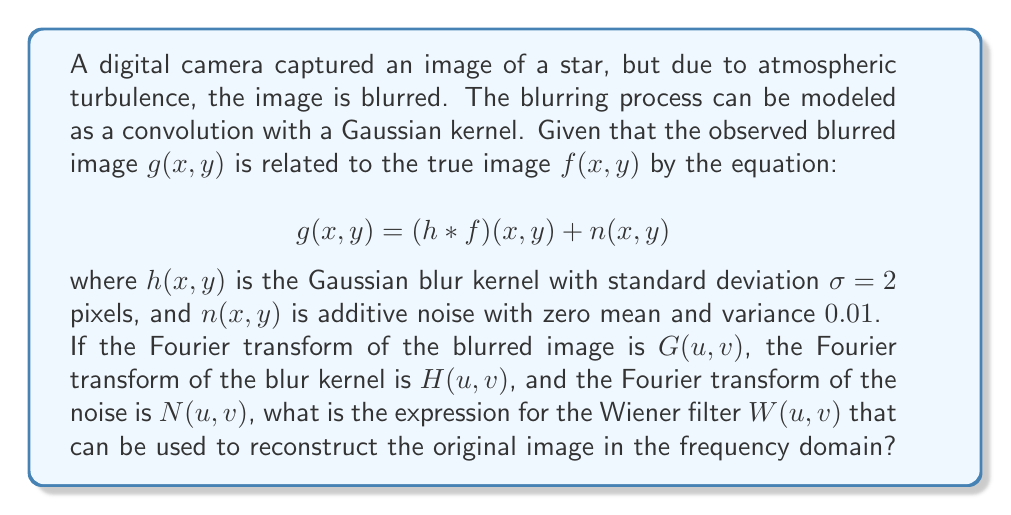Can you answer this question? Let's approach this step-by-step:

1) The Wiener filter is a technique used for deconvolution in the presence of noise. It aims to minimize the mean square error between the estimated and true images.

2) The general form of the Wiener filter in the frequency domain is:

   $$W(u,v) = \frac{H^*(u,v)}{|H(u,v)|^2 + K}$$

   where $H^*(u,v)$ is the complex conjugate of $H(u,v)$, and $K$ is a constant related to the noise-to-signal ratio.

3) For a Gaussian blur kernel with standard deviation $\sigma$, the Fourier transform $H(u,v)$ is:

   $$H(u,v) = e^{-2\pi^2\sigma^2(u^2+v^2)}$$

4) The constant $K$ is typically chosen as the ratio of the noise power spectrum to the signal power spectrum. In this case, we're given that the noise has zero mean and variance 0.01. Assuming the signal and noise are uncorrelated, we can approximate $K$ as:

   $$K \approx \frac{\text{Noise Variance}}{\text{Signal Variance}} = \frac{0.01}{\text{Signal Variance}}$$

5) The signal variance is not given, so we'll leave it as a variable $S$. Thus, $K = \frac{0.01}{S}$.

6) Substituting these into the Wiener filter equation:

   $$W(u,v) = \frac{e^{-2\pi^2\sigma^2(u^2+v^2)}}{e^{-4\pi^2\sigma^2(u^2+v^2)} + \frac{0.01}{S}}$$

7) Simplify by setting $\sigma = 2$ as given in the problem:

   $$W(u,v) = \frac{e^{-8\pi^2(u^2+v^2)}}{e^{-16\pi^2(u^2+v^2)} + \frac{0.01}{S}}$$

This is the final expression for the Wiener filter in this case.
Answer: $$W(u,v) = \frac{e^{-8\pi^2(u^2+v^2)}}{e^{-16\pi^2(u^2+v^2)} + \frac{0.01}{S}}$$ 